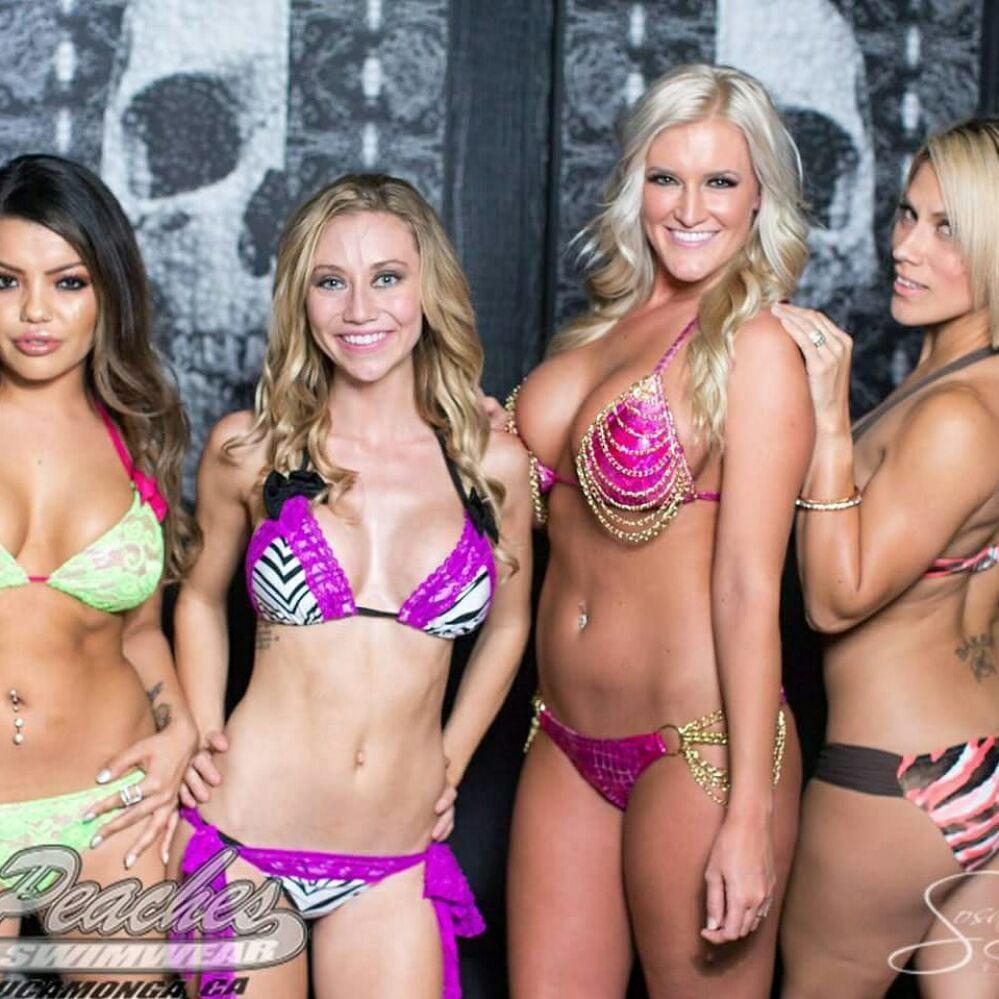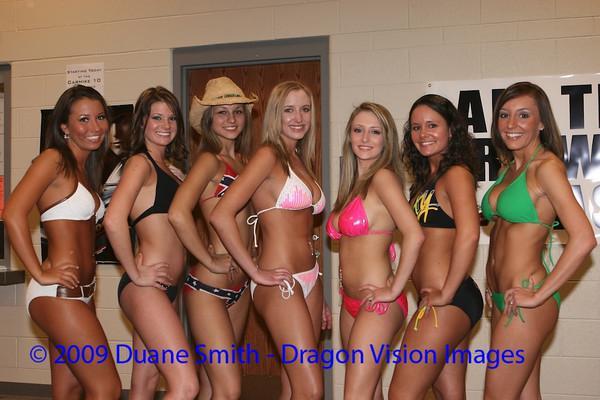The first image is the image on the left, the second image is the image on the right. Considering the images on both sides, is "All bikini models are standing, and no bikini models have their back and rear turned to the camera." valid? Answer yes or no. No. The first image is the image on the left, the second image is the image on the right. Evaluate the accuracy of this statement regarding the images: "One image contains at least 8 women.". Is it true? Answer yes or no. No. 